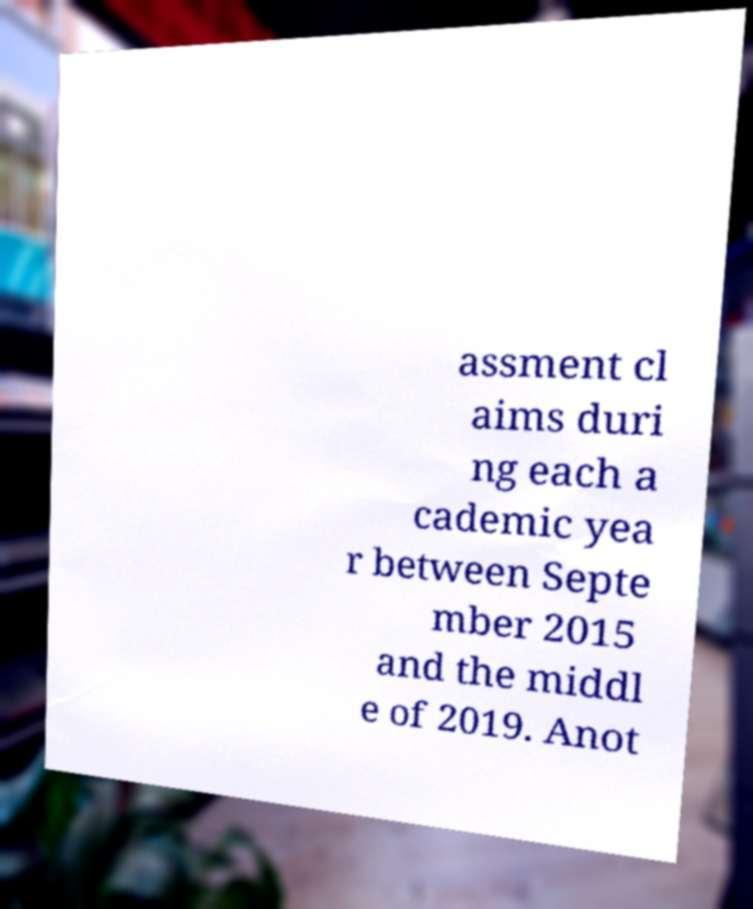What messages or text are displayed in this image? I need them in a readable, typed format. assment cl aims duri ng each a cademic yea r between Septe mber 2015 and the middl e of 2019. Anot 